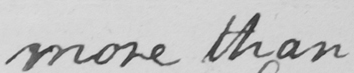Transcribe the text shown in this historical manuscript line. more than 